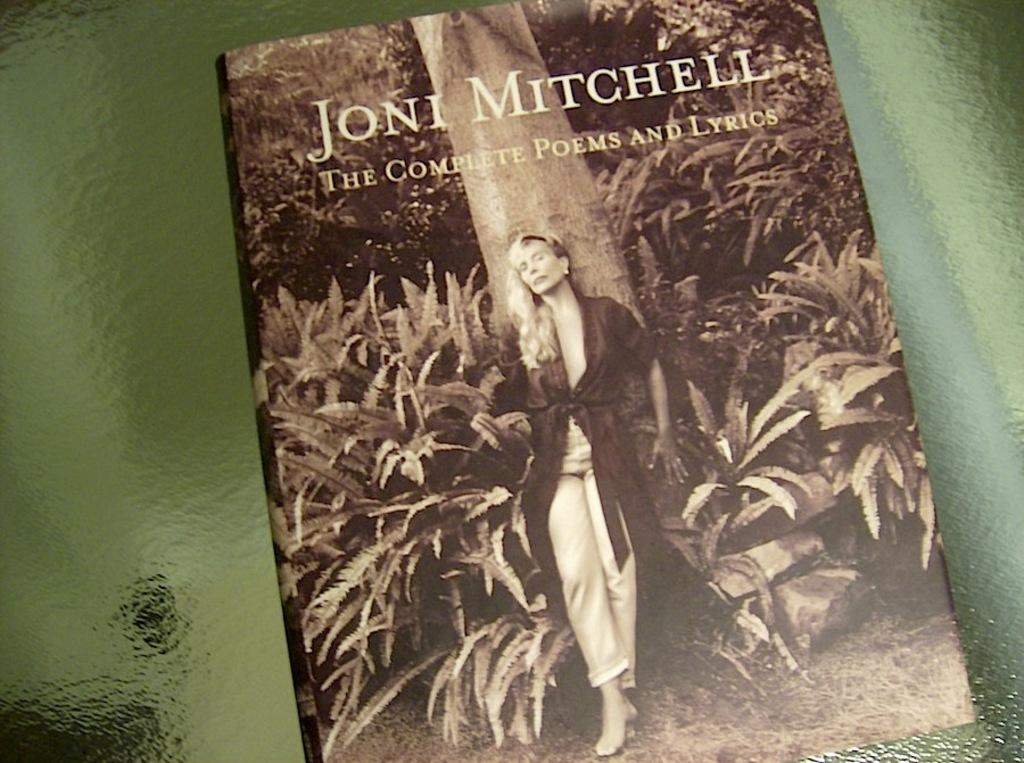<image>
Write a terse but informative summary of the picture. A book titled " The Complete Poems and Lyrics" by Joni Mitchell. 